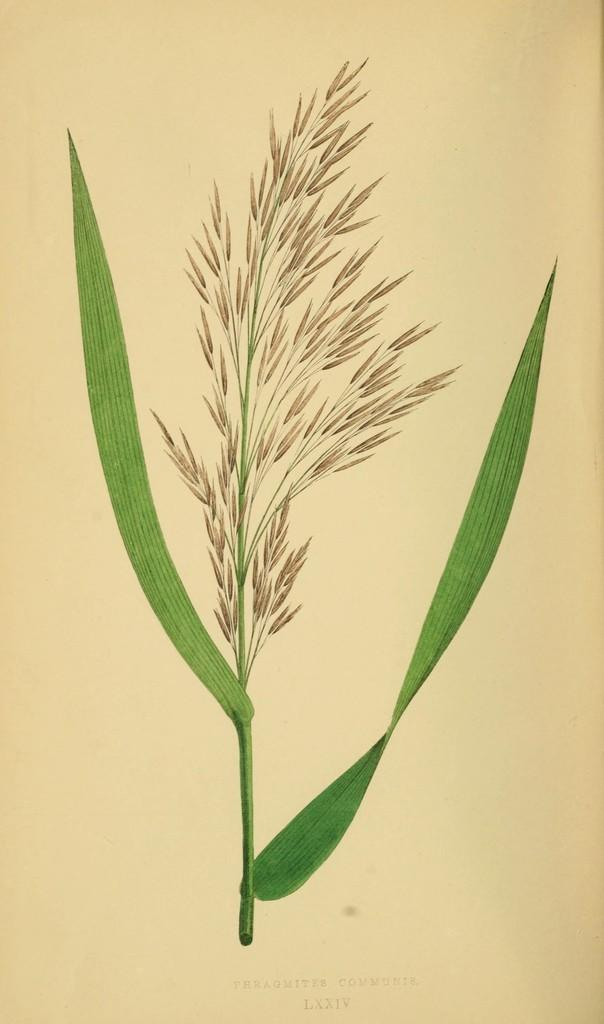What type of living organism is present in the image? The image contains a plant. What color are the leaves of the plant? The plant has green leaves. Is there any text present in the image? Yes, there is text written at the bottom of the image. What type of force is being exerted on the plant in the image? There is no indication of any force being exerted on the plant in the image. 